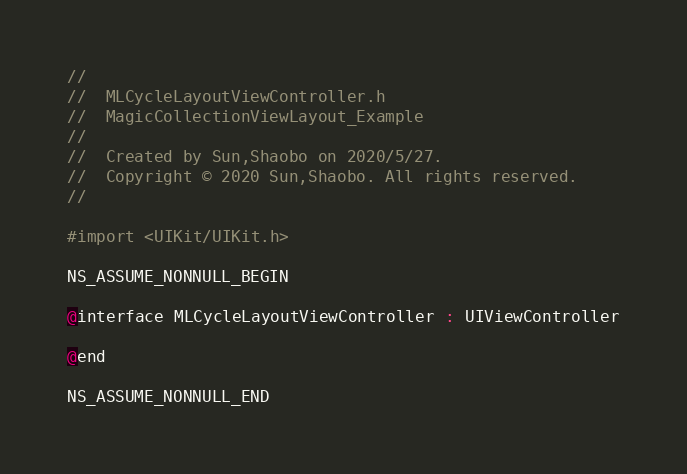<code> <loc_0><loc_0><loc_500><loc_500><_C_>//
//  MLCycleLayoutViewController.h
//  MagicCollectionViewLayout_Example
//
//  Created by Sun,Shaobo on 2020/5/27.
//  Copyright © 2020 Sun,Shaobo. All rights reserved.
//

#import <UIKit/UIKit.h>

NS_ASSUME_NONNULL_BEGIN

@interface MLCycleLayoutViewController : UIViewController

@end

NS_ASSUME_NONNULL_END
</code> 